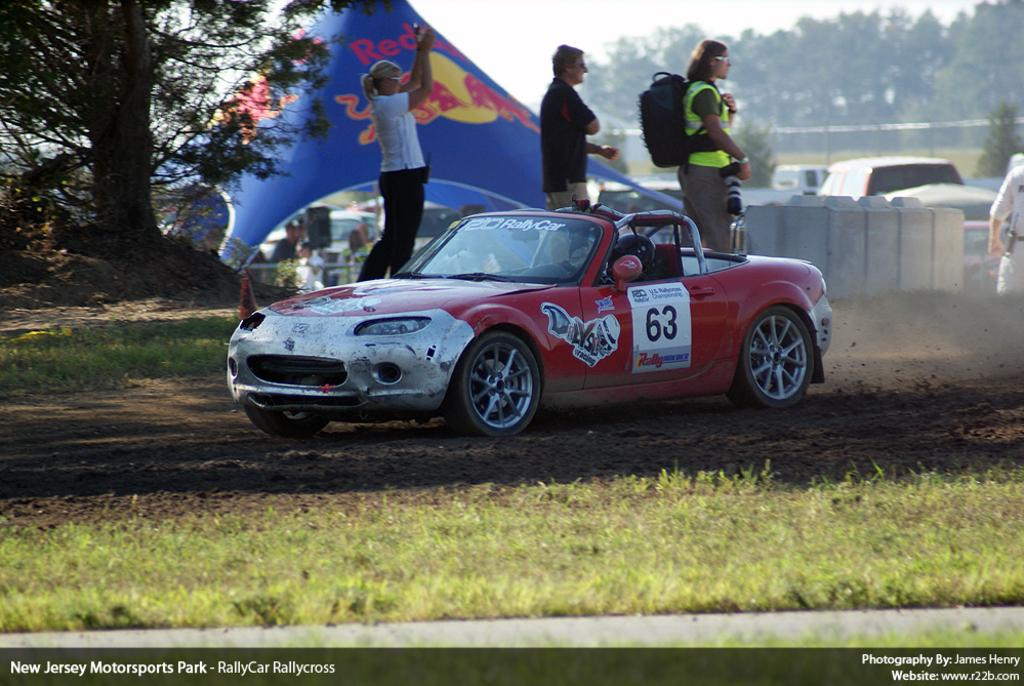What type of shelter is present in the image? There is a tent in the image. What natural elements can be seen in the image? There are trees and the sky visible in the image. What type of transportation is present in the image? There are motor vehicles in the image. What are the people in the image doing? There are persons standing on the ground in the image. What structures are present in the image? There are poles in the image. What type of rabbit can be seen hopping near the tent in the image? There is no rabbit present in the image; only the tent, trees, sky, motor vehicles, persons, and poles are visible. What type of earth is visible in the image? The image does not show any specific type of earth; it only shows the ground where the persons are standing. 